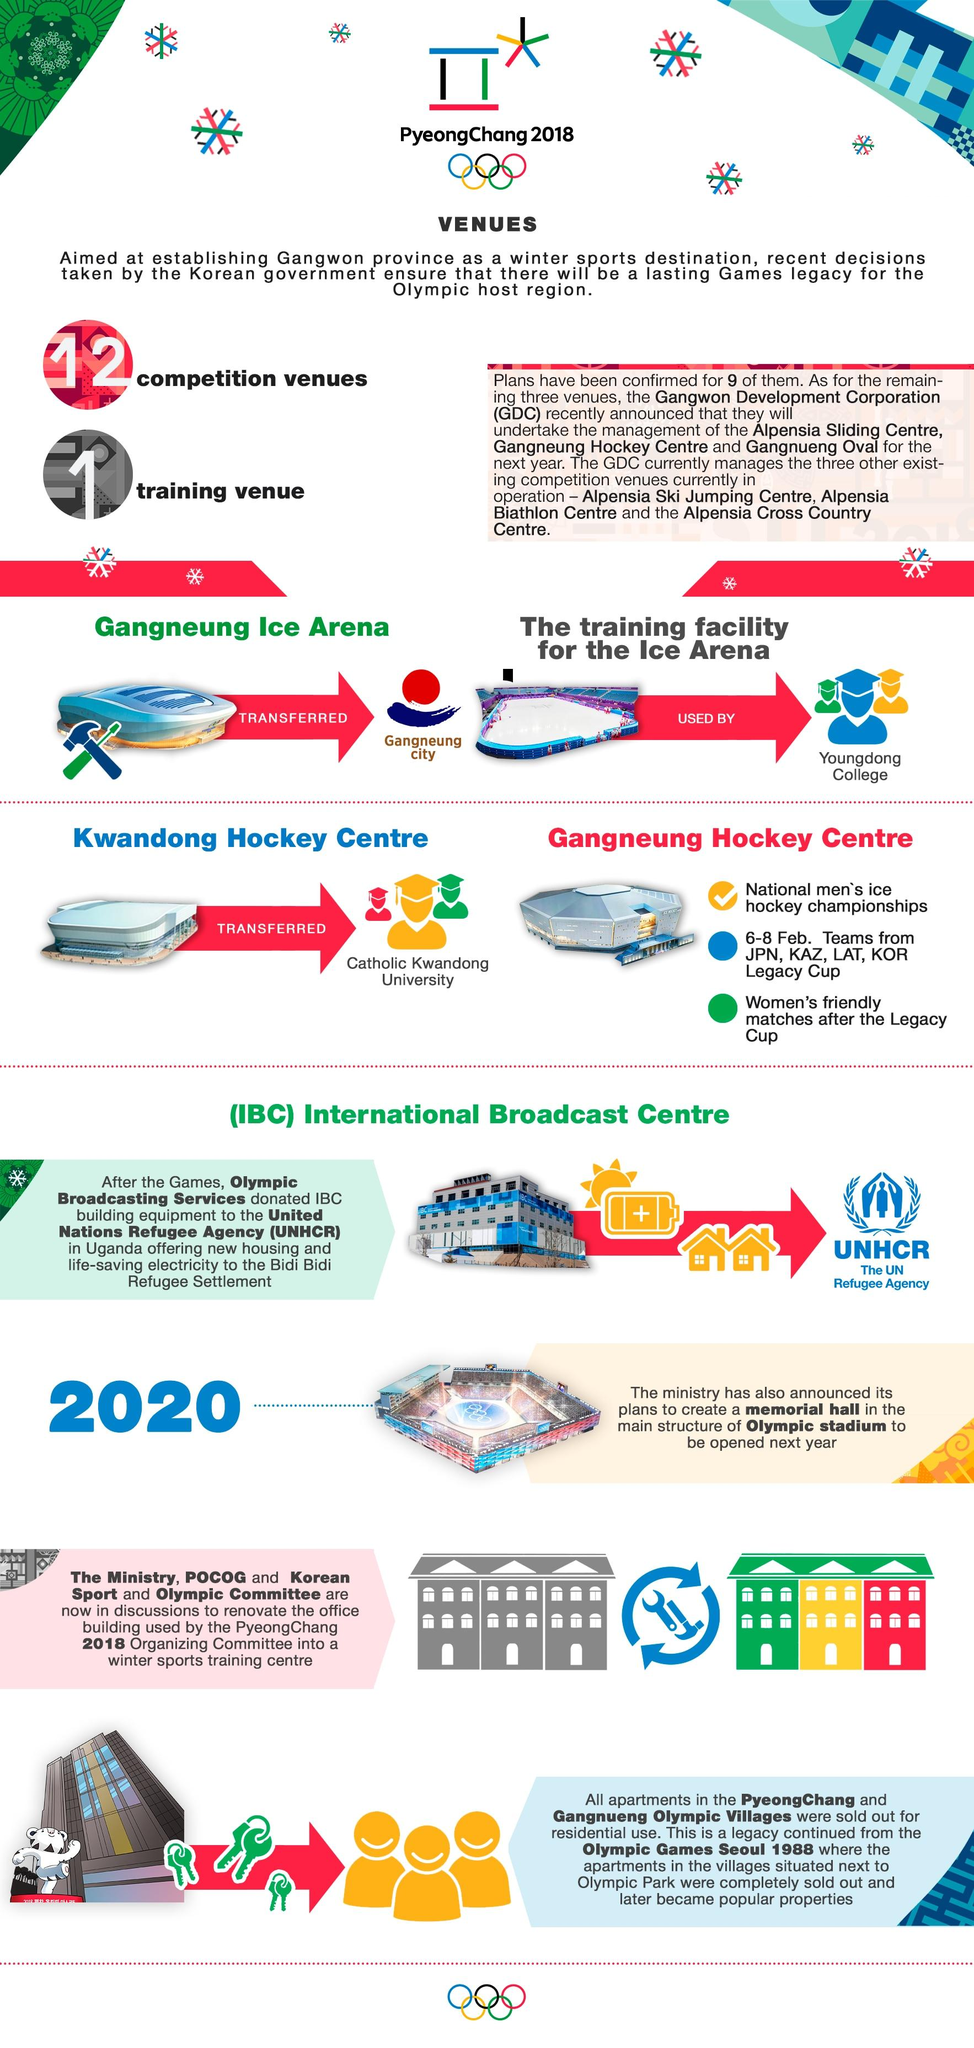Outline some significant characteristics in this image. After the winter Olympics of 2018, Catholic Kwandong University is using the Kwandong Hockey center. After the Legacy Cup, women's friendly matches were held at the Gangneung Hockey Centre. The Legacy Cup, a hockey event held from February 6-8 at the Gangneung Hockey Centre, was a memorable event that left a lasting legacy. The Legacy cup was held at the Gangneung Hockey Centre, which was the venue for the hockey events at the 2018 Winter Olympics in Gangneung, South Korea. Four teams participated in the Legacy Cup hockey tournament. 